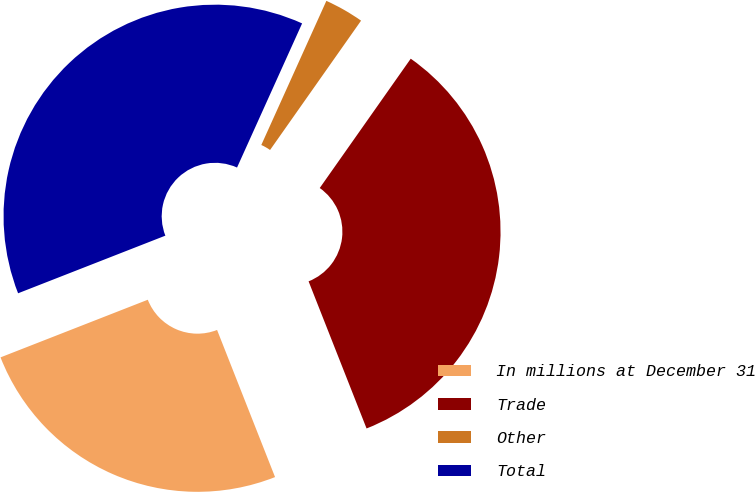Convert chart. <chart><loc_0><loc_0><loc_500><loc_500><pie_chart><fcel>In millions at December 31<fcel>Trade<fcel>Other<fcel>Total<nl><fcel>25.04%<fcel>34.27%<fcel>3.01%<fcel>37.69%<nl></chart> 